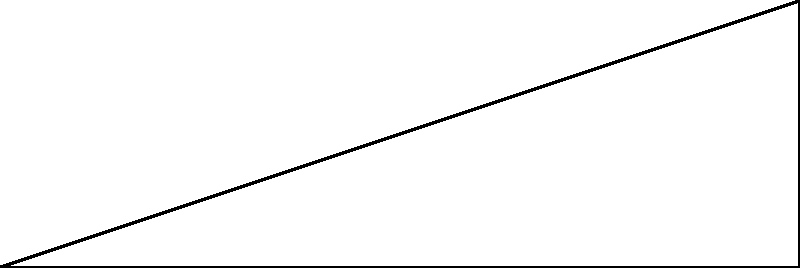As an RAF cadet preparing for takeoff, you need to calculate the angle of elevation for the aircraft. The runway is $6000$ feet long, and the aircraft needs to reach an altitude of $2000$ feet at the end of the runway. What is the angle of elevation ($\theta$) for the aircraft's takeoff path? To solve this problem, we'll use trigonometry in a right triangle:

1) We have a right triangle where:
   - The base (adjacent side) is $6000$ feet (length of the runway)
   - The height (opposite side) is $2000$ feet (altitude at the end of the runway)
   - We need to find the angle $\theta$

2) We can use the tangent function, which is defined as:

   $\tan(\theta) = \frac{\text{opposite}}{\text{adjacent}}$

3) Plugging in our values:

   $\tan(\theta) = \frac{2000}{6000}$

4) Simplify the fraction:

   $\tan(\theta) = \frac{1}{3}$

5) To find $\theta$, we need to use the inverse tangent (arctan) function:

   $\theta = \arctan(\frac{1}{3})$

6) Using a calculator or trigonometric tables:

   $\theta \approx 18.43^\circ$

7) Rounding to the nearest degree:

   $\theta \approx 18^\circ$
Answer: $18^\circ$ 